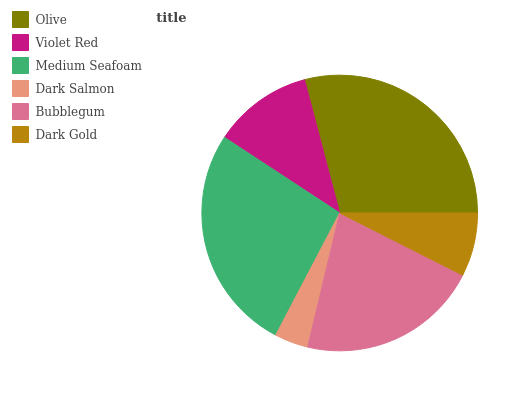Is Dark Salmon the minimum?
Answer yes or no. Yes. Is Olive the maximum?
Answer yes or no. Yes. Is Violet Red the minimum?
Answer yes or no. No. Is Violet Red the maximum?
Answer yes or no. No. Is Olive greater than Violet Red?
Answer yes or no. Yes. Is Violet Red less than Olive?
Answer yes or no. Yes. Is Violet Red greater than Olive?
Answer yes or no. No. Is Olive less than Violet Red?
Answer yes or no. No. Is Bubblegum the high median?
Answer yes or no. Yes. Is Violet Red the low median?
Answer yes or no. Yes. Is Dark Gold the high median?
Answer yes or no. No. Is Medium Seafoam the low median?
Answer yes or no. No. 